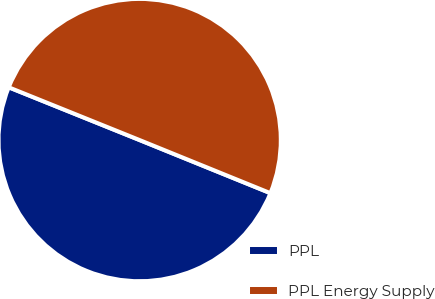<chart> <loc_0><loc_0><loc_500><loc_500><pie_chart><fcel>PPL<fcel>PPL Energy Supply<nl><fcel>49.96%<fcel>50.04%<nl></chart> 